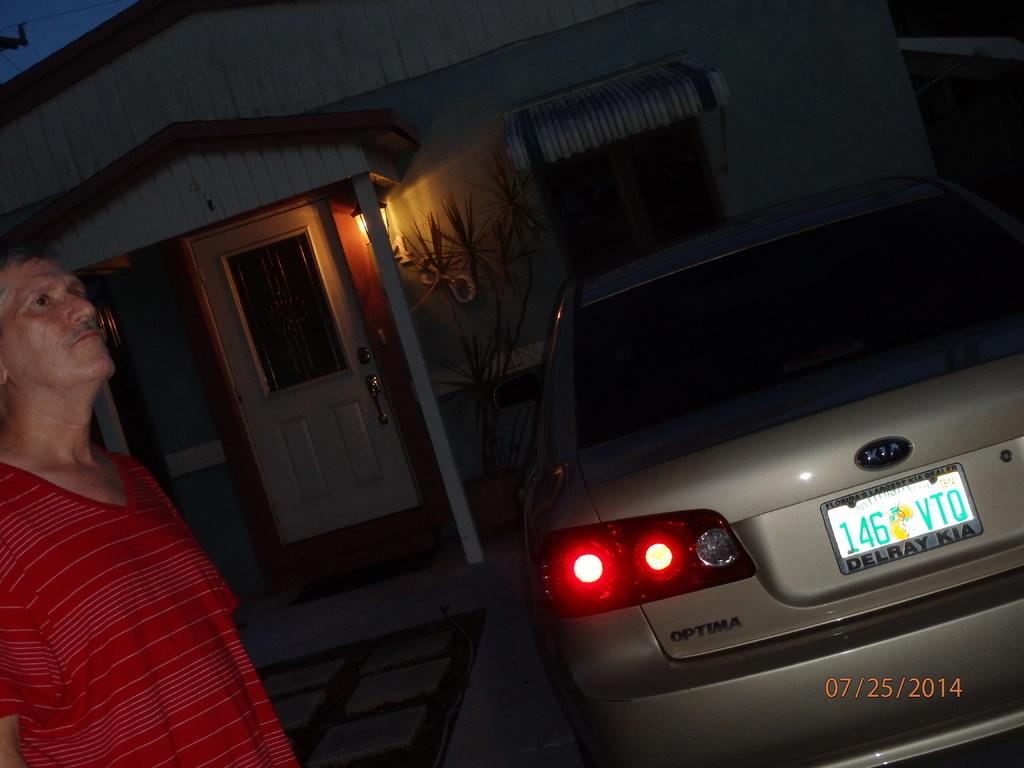<image>
Share a concise interpretation of the image provided. A KIA Optima has a license plate frame that reads, in part, "Delray KIA." 